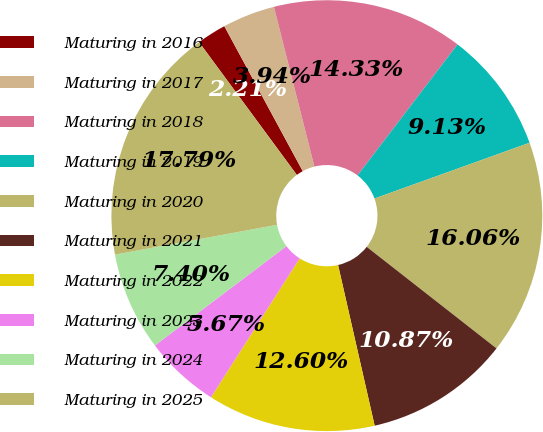Convert chart to OTSL. <chart><loc_0><loc_0><loc_500><loc_500><pie_chart><fcel>Maturing in 2016<fcel>Maturing in 2017<fcel>Maturing in 2018<fcel>Maturing in 2019<fcel>Maturing in 2020<fcel>Maturing in 2021<fcel>Maturing in 2022<fcel>Maturing in 2023<fcel>Maturing in 2024<fcel>Maturing in 2025<nl><fcel>2.21%<fcel>3.94%<fcel>14.33%<fcel>9.13%<fcel>16.06%<fcel>10.87%<fcel>12.6%<fcel>5.67%<fcel>7.4%<fcel>17.79%<nl></chart> 